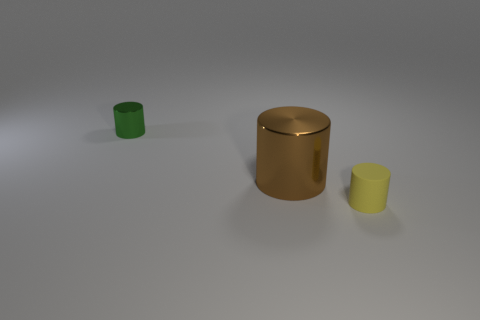Subtract all tiny cylinders. How many cylinders are left? 1 Add 3 tiny purple rubber spheres. How many objects exist? 6 Subtract all yellow cylinders. How many cylinders are left? 2 Add 2 tiny cylinders. How many tiny cylinders are left? 4 Add 1 tiny red matte things. How many tiny red matte things exist? 1 Subtract 0 purple spheres. How many objects are left? 3 Subtract all gray cylinders. Subtract all green cubes. How many cylinders are left? 3 Subtract all tiny cylinders. Subtract all large purple metallic spheres. How many objects are left? 1 